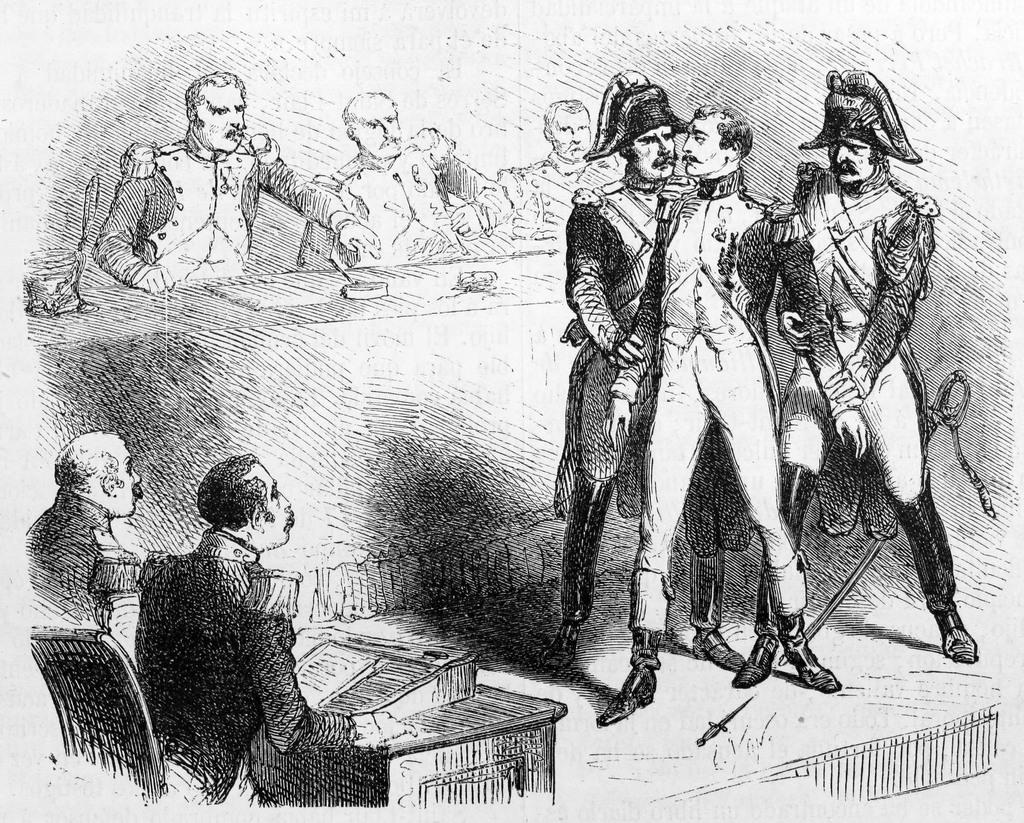Please provide a concise description of this image. In the image in the center we can see one paper. On paper,on the left side we can see two persons were sitting on the chair and there is a table and book. In the center we can see three persons were sitting on the chair. In front of them there is a table. On table,we can see hammer and few other objects. And on the right side we can see three persons were standing and they were in different costumes. 